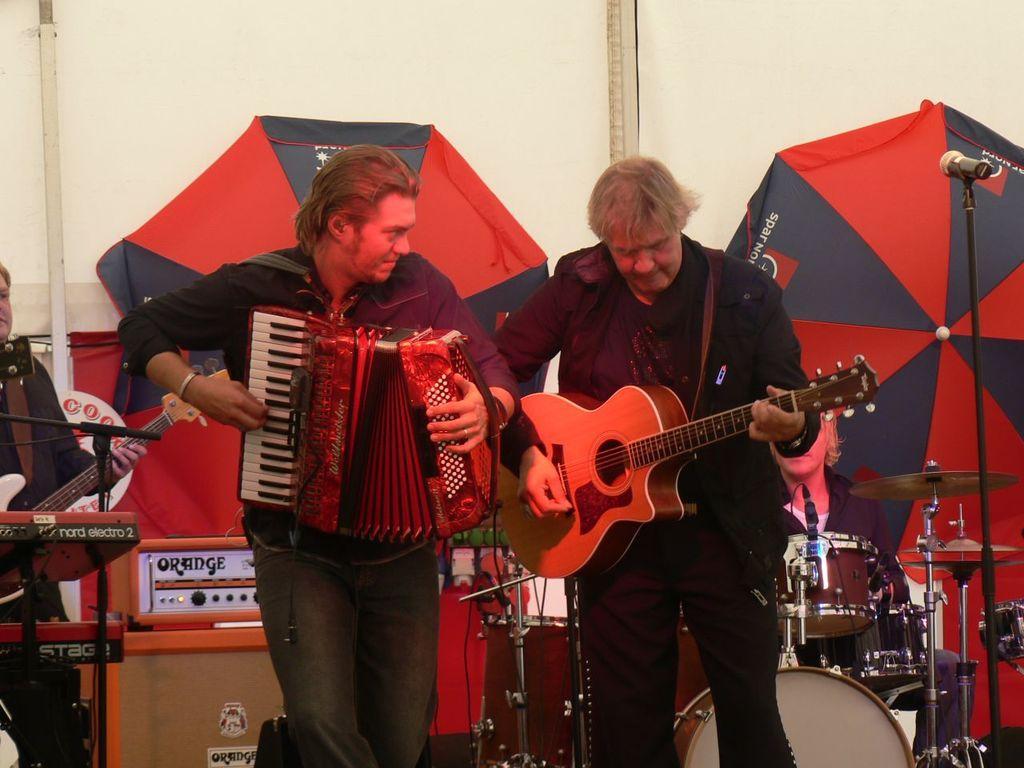In one or two sentences, can you explain what this image depicts? It is a room , there are three people inside the room, the first person wearing black dress is playing guitar ,the person left him is playing another instrument and third person is also playing the guitar there is also a mic in front of third person so he might be singing also, in the background there are some drums, behind that there is an umbrella, behind the umbrella there is a white color wall. 